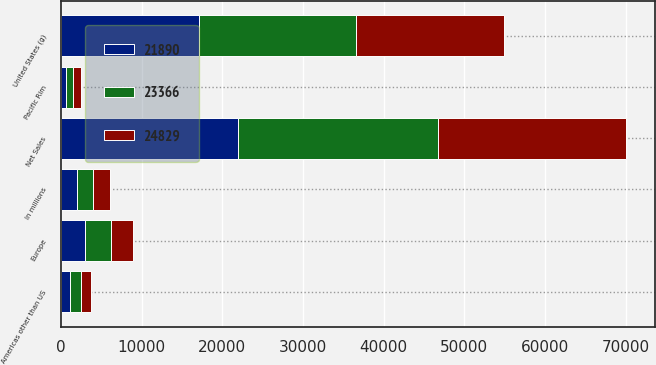Convert chart to OTSL. <chart><loc_0><loc_0><loc_500><loc_500><stacked_bar_chart><ecel><fcel>In millions<fcel>United States (g)<fcel>Europe<fcel>Pacific Rim<fcel>Americas other than US<fcel>Net Sales<nl><fcel>24829<fcel>2009<fcel>18355<fcel>2716<fcel>1002<fcel>1293<fcel>23366<nl><fcel>23366<fcel>2008<fcel>19501<fcel>3177<fcel>827<fcel>1324<fcel>24829<nl><fcel>21890<fcel>2007<fcel>17096<fcel>2986<fcel>678<fcel>1130<fcel>21890<nl></chart> 